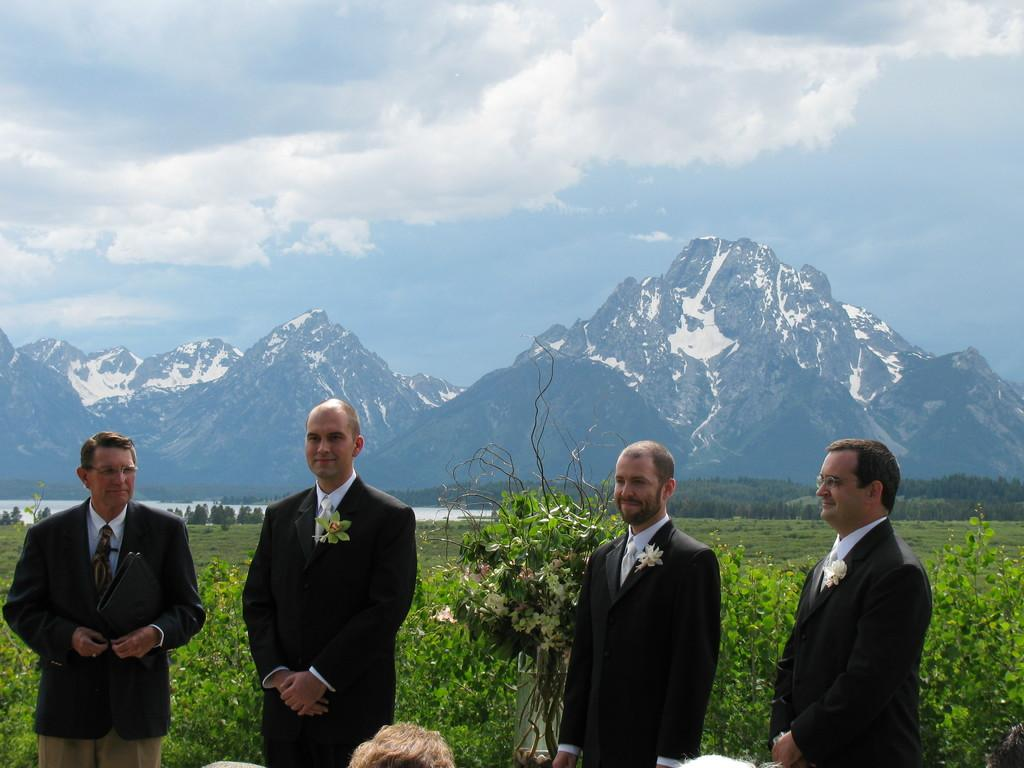How many men are in the image? There are four men in the image. What are the men doing in the image? The men are standing in the image. What are the men wearing in the image? The men are wearing black coats, ties, and white shirts in the image. What can be seen in the background of the image? There are mountains in the image, and the sky is cloudy. What type of dog can be seen playing with a bottle in the image? There is no dog or bottle present in the image; it features four men standing in front of mountains with a cloudy sky. 